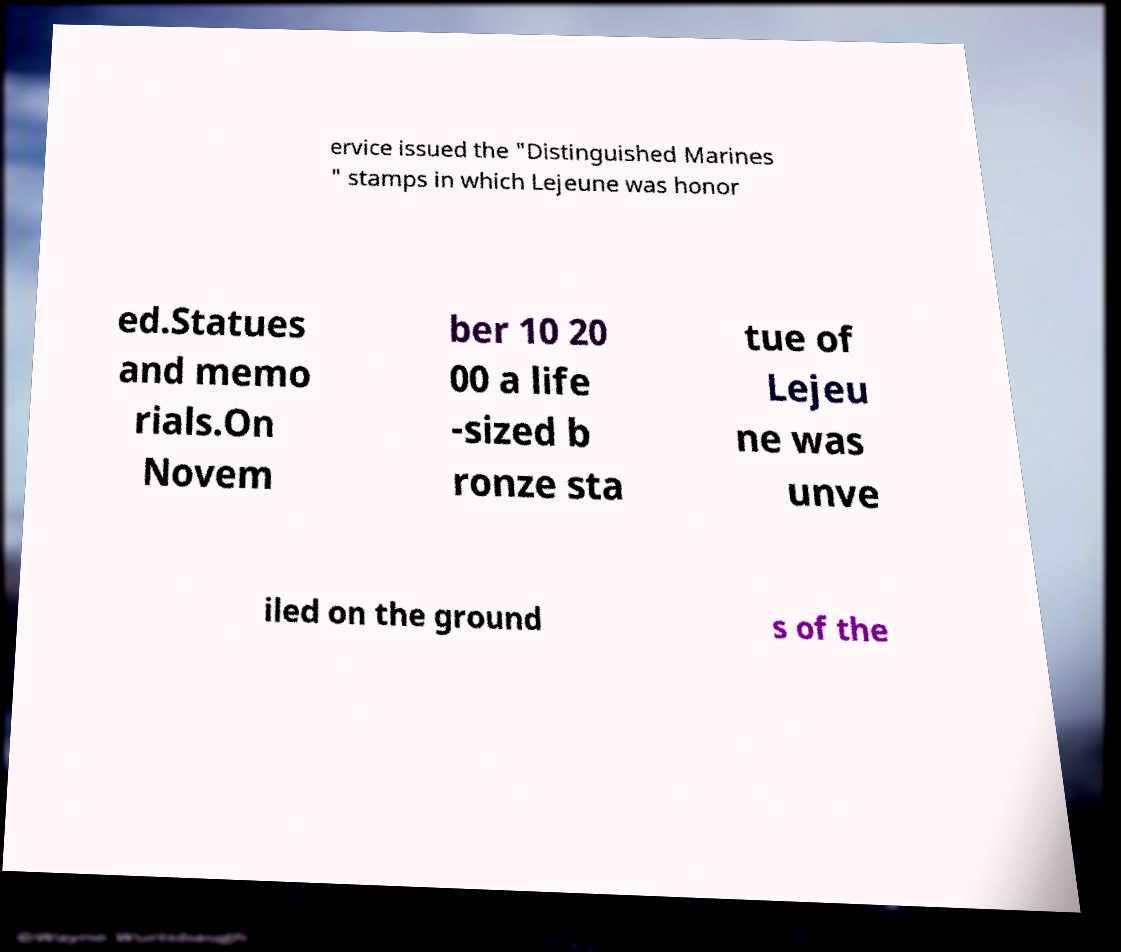Can you accurately transcribe the text from the provided image for me? ervice issued the "Distinguished Marines " stamps in which Lejeune was honor ed.Statues and memo rials.On Novem ber 10 20 00 a life -sized b ronze sta tue of Lejeu ne was unve iled on the ground s of the 